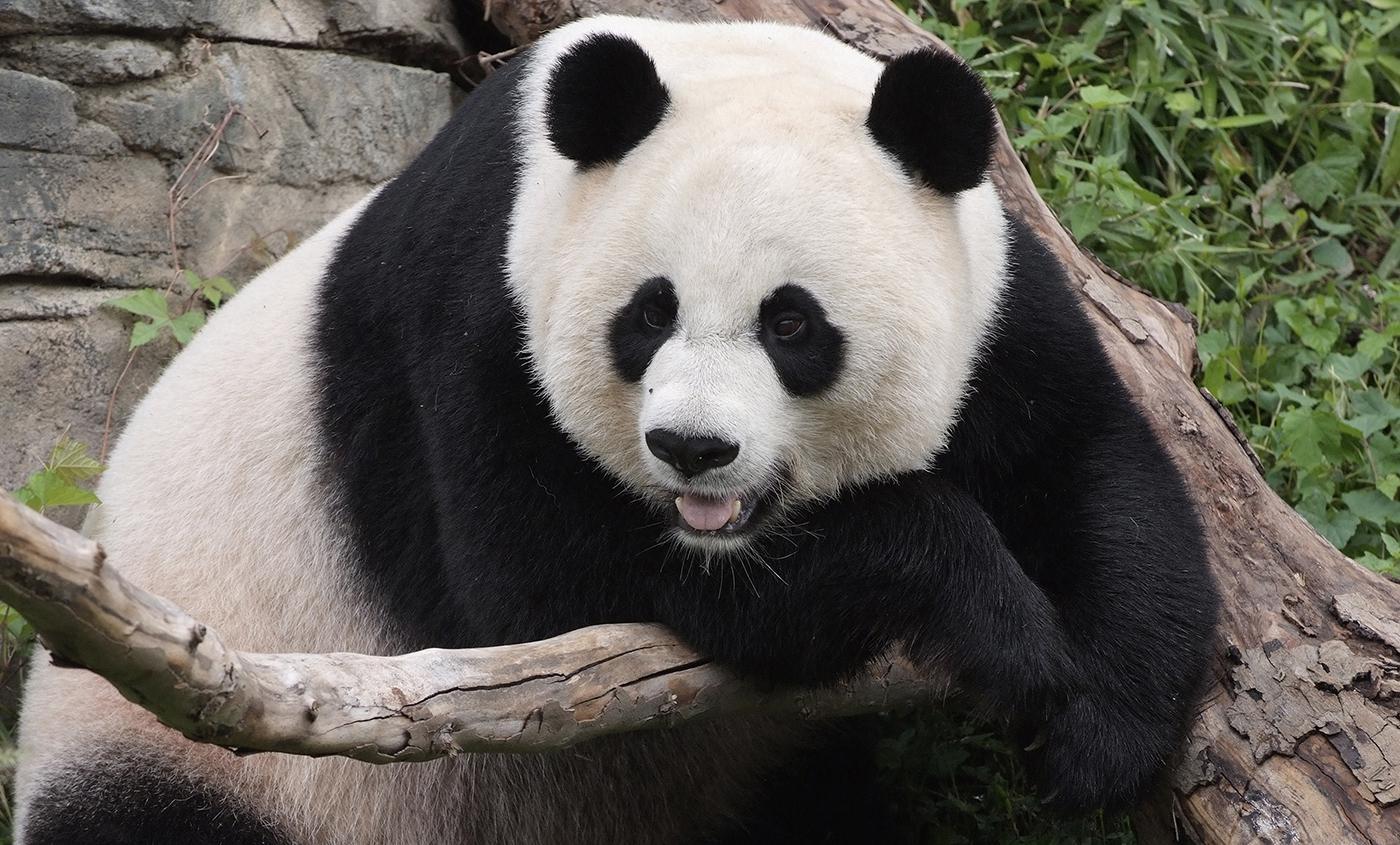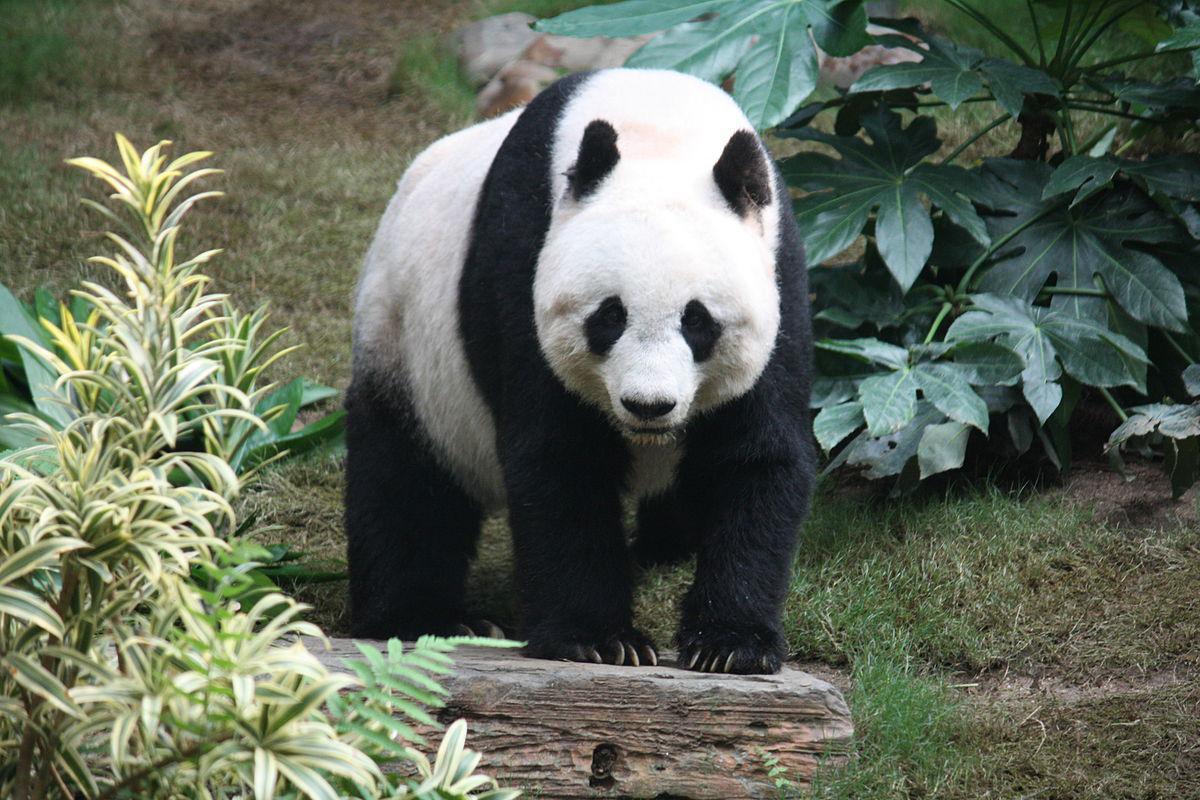The first image is the image on the left, the second image is the image on the right. Evaluate the accuracy of this statement regarding the images: "An image shows a panda with paws over a horizontal  tree limb.". Is it true? Answer yes or no. Yes. The first image is the image on the left, the second image is the image on the right. Evaluate the accuracy of this statement regarding the images: "At least one of the pandas is holding onto a tree branch.". Is it true? Answer yes or no. Yes. 